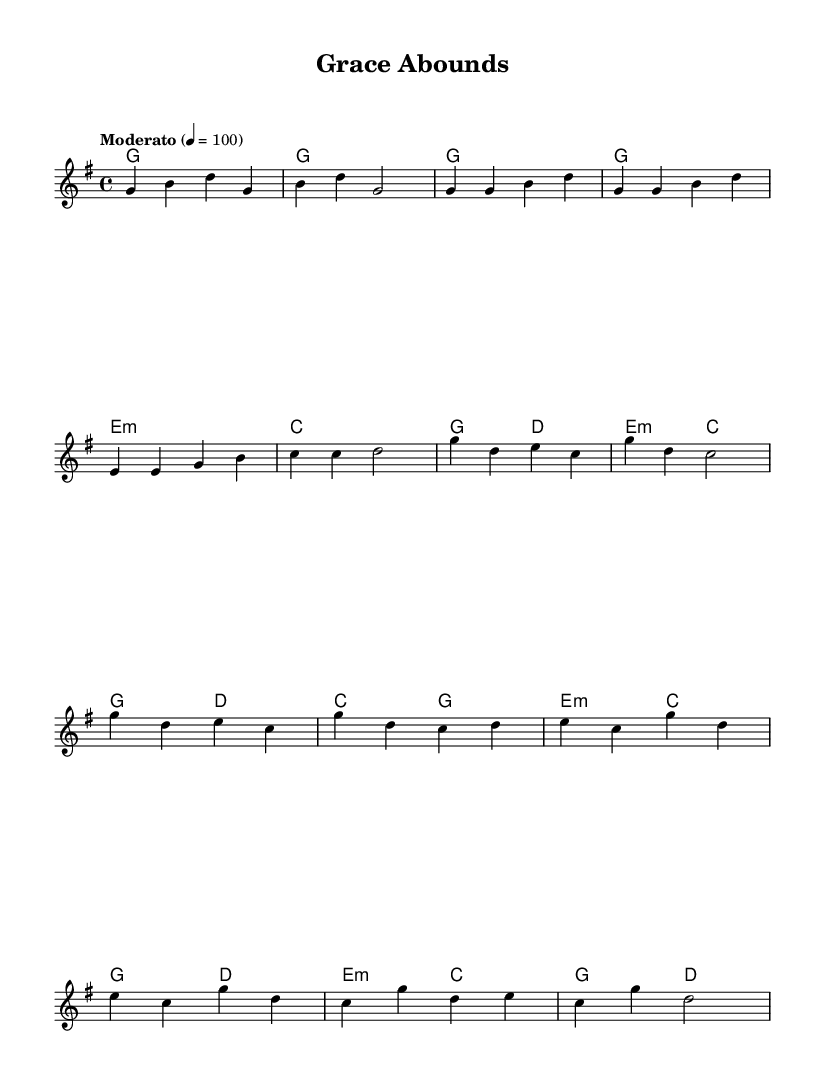What is the key signature of this music? The key signature is G major, which contains one sharp (F#). This can be determined from the key indication at the beginning of the score.
Answer: G major What is the time signature used in this piece? The time signature is 4/4, indicated after the key signature at the beginning of the score. This means there are four beats in each measure.
Answer: 4/4 What is the tempo marking for this piece? The tempo marking is "Moderato," which is typically understood to mean a moderate speed. The numerical tempo marking given is 100 beats per minute.
Answer: Moderato How many measures are there in the verse? The verse consists of 4 measures, as can be counted from the melody section for the verse, where each set of notes ends with a bar line.
Answer: 4 What is the first note of the chorus? The first note of the chorus is G, which can be seen at the start of the chorus section in the melody.
Answer: G Which chord is played during the bridge? The chords during the bridge include E minor, C, G, and D. The first chord specifically shown in the bridge is E minor, which can be identified at the start of that section.
Answer: E minor What is the overall theme of the lyrics in this song? The overall theme focuses on grace and mercy, which is indicated by lines in the lyrics expressing support and unconditional love from a higher power. The specific introductory line indicates uncertainty met with true love.
Answer: Grace and mercy 